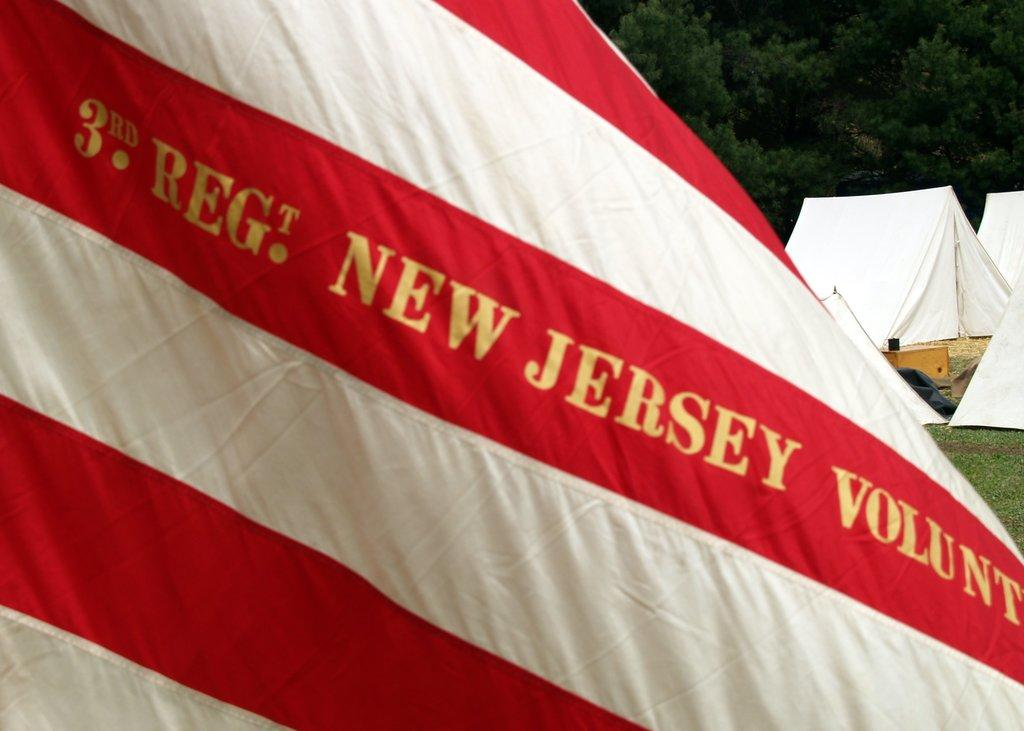What is the main feature of the flag in the image? The flag in the image is red and white with text. What type of structures can be seen in the background of the image? There are tents in the background of the image. What type of vegetation is visible in the background of the image? There are trees and grass in the background of the image. What else can be seen in the background of the image? There are other objects in the background of the image. How many sheep are visible in the image? There are no sheep present in the image. What type of hall can be seen in the background of the image? There is no hall present in the image. 